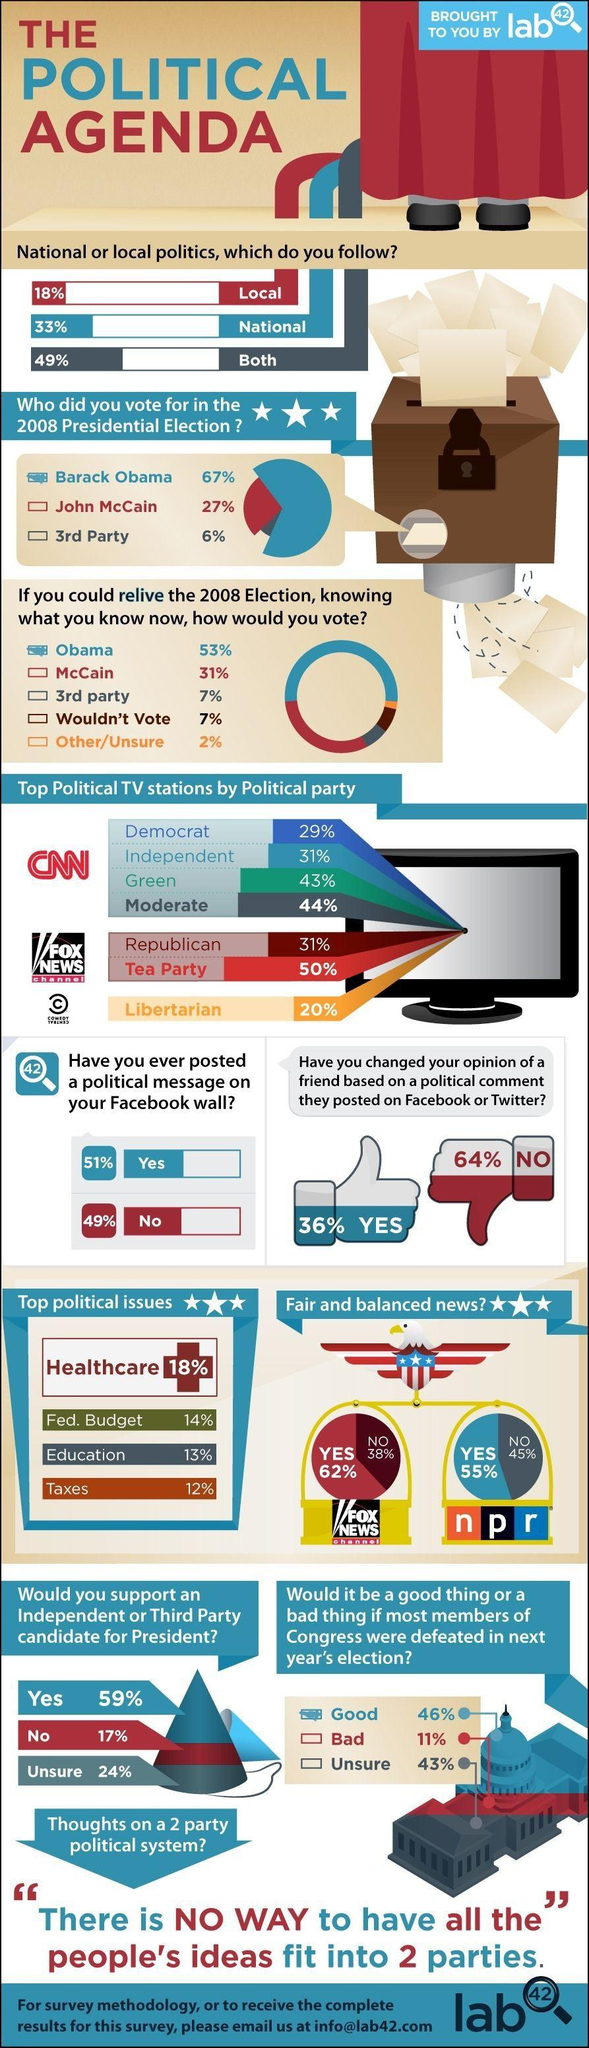Specify some key components in this picture. The second most important political issue after healthcare is the federal budget. Most people believe that Fox News Channel provides fair and balanced news. According to the survey, 49% of Americans have never posted a political message on their Facebook wall. According to the survey, 49% of Americans follow both national and local politics. According to a survey, 27% of Americans voted for John McCain in the 2008 Presidential Election. 